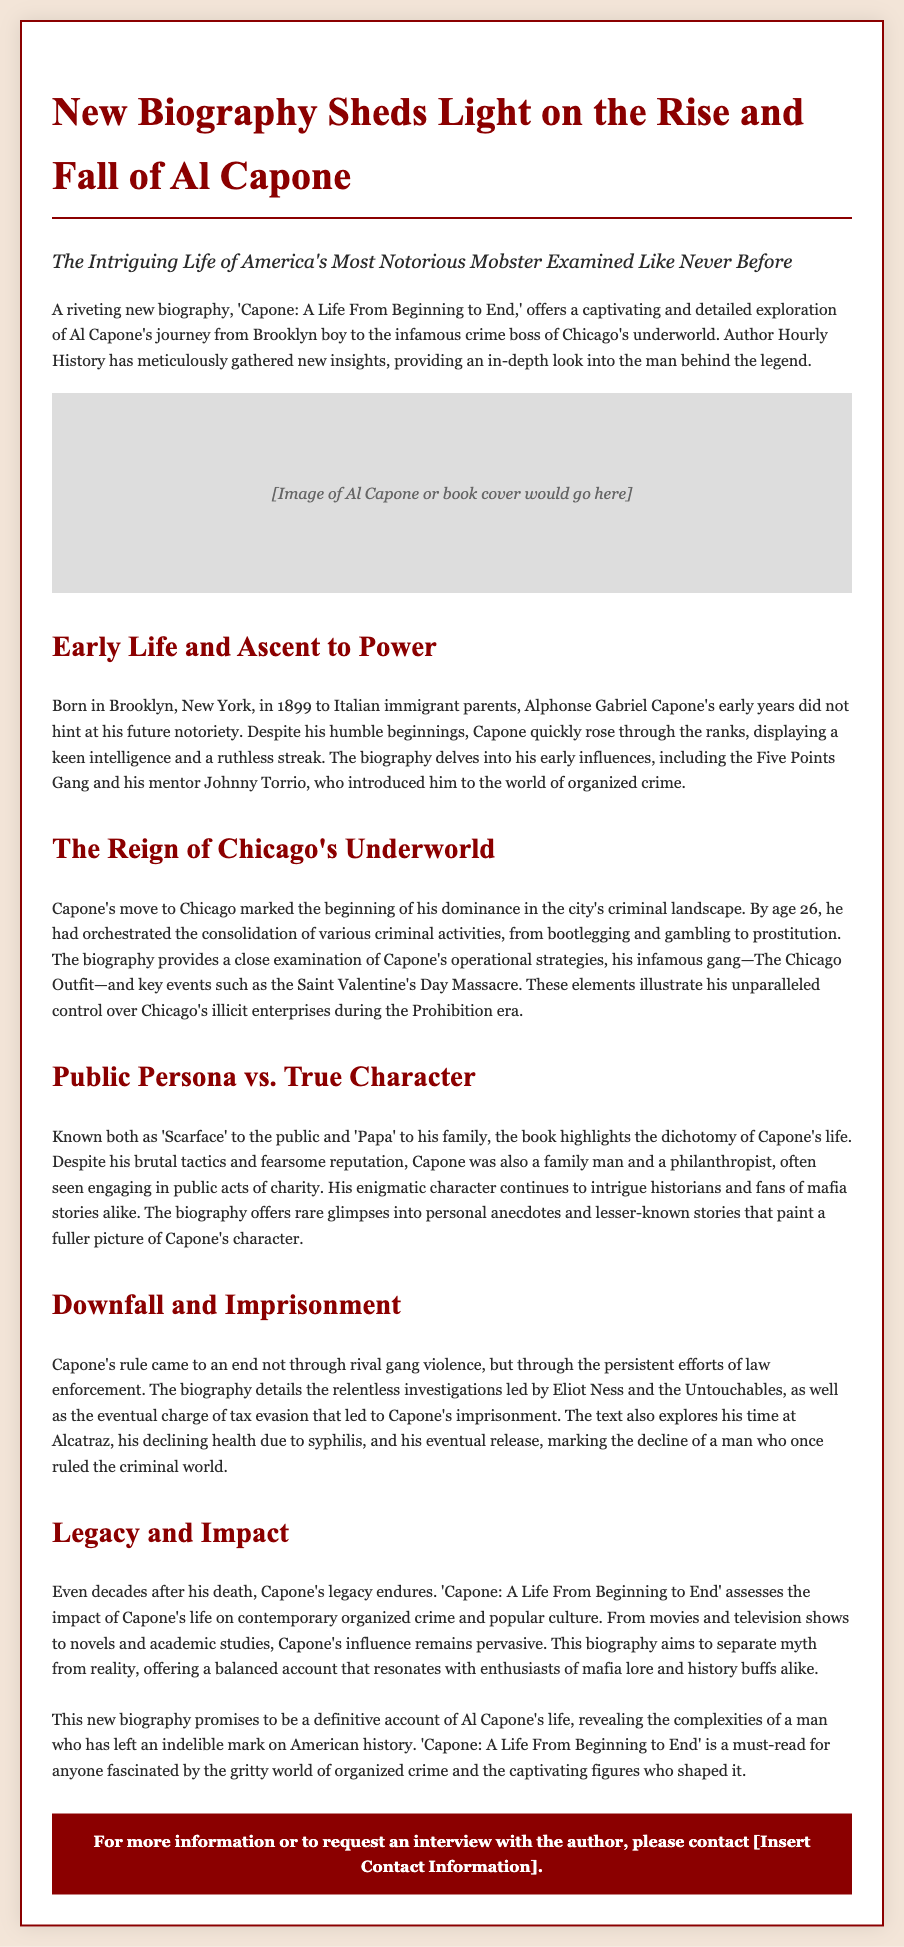What is the title of the biography? The title of the biography is stated prominently in the press release.
Answer: Capone: A Life From Beginning to End Who is the author of the biography? The press release mentions the author at the beginning of the text.
Answer: Hourly History What year was Al Capone born? The biography gives Capone's birth year in the context of his early life.
Answer: 1899 What was Al Capone's nickname mentioned in the document? The document refers to Capone by a nickname he was known by in public.
Answer: Scarface What crime led to Al Capone's imprisonment? The press release highlights a specific charge that resulted in his downfall.
Answer: Tax evasion At what age did Capone orchestrate the consolidation of various criminal activities? The document specifies Capone's age when he became dominant in organized crime.
Answer: 26 What was the name of Capone's infamous gang? The press release identifies the name of the gang associated with Capone's operations.
Answer: The Chicago Outfit What event marked a significant moment in Capone's reign? The document lists an important historical event that highlighted Capone's violence.
Answer: The Saint Valentine's Day Massacre Which prison is mentioned where Capone was held? The biography provides the name of the prison where Capone served time.
Answer: Alcatraz 